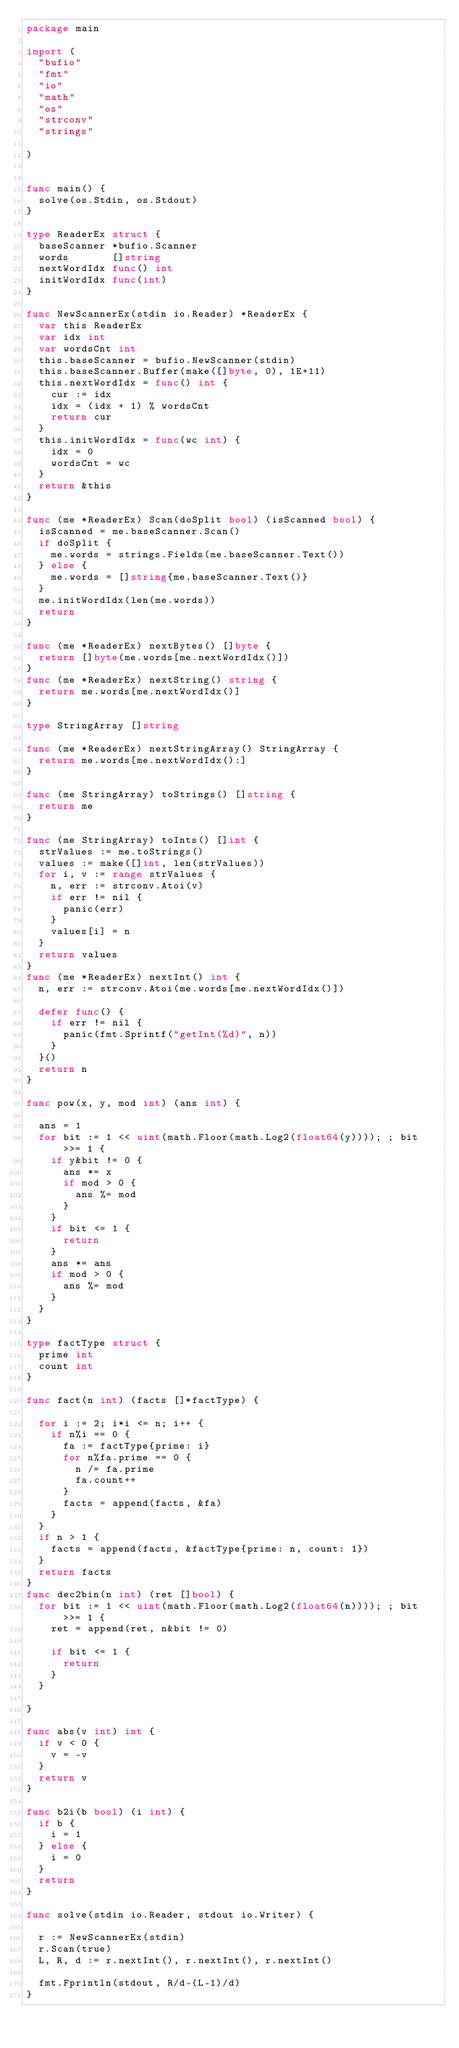<code> <loc_0><loc_0><loc_500><loc_500><_Go_>package main

import (
	"bufio"
	"fmt"
	"io"
	"math"
	"os"
	"strconv"
	"strings"

)


func main() {
	solve(os.Stdin, os.Stdout)
}

type ReaderEx struct {
	baseScanner *bufio.Scanner
	words       []string
	nextWordIdx func() int
	initWordIdx func(int)
}

func NewScannerEx(stdin io.Reader) *ReaderEx {
	var this ReaderEx
	var idx int
	var wordsCnt int
	this.baseScanner = bufio.NewScanner(stdin)
	this.baseScanner.Buffer(make([]byte, 0), 1E+11)
	this.nextWordIdx = func() int {
		cur := idx
		idx = (idx + 1) % wordsCnt
		return cur
	}
	this.initWordIdx = func(wc int) {
		idx = 0
		wordsCnt = wc
	}
	return &this
}

func (me *ReaderEx) Scan(doSplit bool) (isScanned bool) {
	isScanned = me.baseScanner.Scan()
	if doSplit {
		me.words = strings.Fields(me.baseScanner.Text())
	} else {
		me.words = []string{me.baseScanner.Text()}
	}
	me.initWordIdx(len(me.words))
	return
}

func (me *ReaderEx) nextBytes() []byte {
	return []byte(me.words[me.nextWordIdx()])
}
func (me *ReaderEx) nextString() string {
	return me.words[me.nextWordIdx()]
}

type StringArray []string

func (me *ReaderEx) nextStringArray() StringArray {
	return me.words[me.nextWordIdx():]
}

func (me StringArray) toStrings() []string {
	return me
}

func (me StringArray) toInts() []int {
	strValues := me.toStrings()
	values := make([]int, len(strValues))
	for i, v := range strValues {
		n, err := strconv.Atoi(v)
		if err != nil {
			panic(err)
		}
		values[i] = n
	}
	return values
}
func (me *ReaderEx) nextInt() int {
	n, err := strconv.Atoi(me.words[me.nextWordIdx()])

	defer func() {
		if err != nil {
			panic(fmt.Sprintf("getInt(%d)", n))
		}
	}()
	return n
}

func pow(x, y, mod int) (ans int) {

	ans = 1
	for bit := 1 << uint(math.Floor(math.Log2(float64(y)))); ; bit >>= 1 {
		if y&bit != 0 {
			ans *= x
			if mod > 0 {
				ans %= mod
			}
		}
		if bit <= 1 {
			return
		}
		ans *= ans
		if mod > 0 {
			ans %= mod
		}
	}
}

type factType struct {
	prime int
	count int
}

func fact(n int) (facts []*factType) {

	for i := 2; i*i <= n; i++ {
		if n%i == 0 {
			fa := factType{prime: i}
			for n%fa.prime == 0 {
				n /= fa.prime
				fa.count++
			}
			facts = append(facts, &fa)
		}
	}
	if n > 1 {
		facts = append(facts, &factType{prime: n, count: 1})
	}
	return facts
}
func dec2bin(n int) (ret []bool) {
	for bit := 1 << uint(math.Floor(math.Log2(float64(n)))); ; bit >>= 1 {
		ret = append(ret, n&bit != 0)

		if bit <= 1 {
			return
		}
	}

}

func abs(v int) int {
	if v < 0 {
		v = -v
	}
	return v
}

func b2i(b bool) (i int) {
	if b {
		i = 1
	} else {
		i = 0
	}
	return
}

func solve(stdin io.Reader, stdout io.Writer) {

	r := NewScannerEx(stdin)
	r.Scan(true)
	L, R, d := r.nextInt(), r.nextInt(), r.nextInt()

	fmt.Fprintln(stdout, R/d-(L-1)/d)
}
</code> 